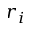Convert formula to latex. <formula><loc_0><loc_0><loc_500><loc_500>r _ { i }</formula> 